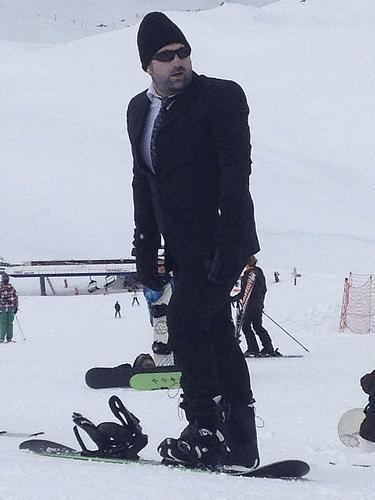How many of the people wear sunglasses?
Give a very brief answer. 1. 